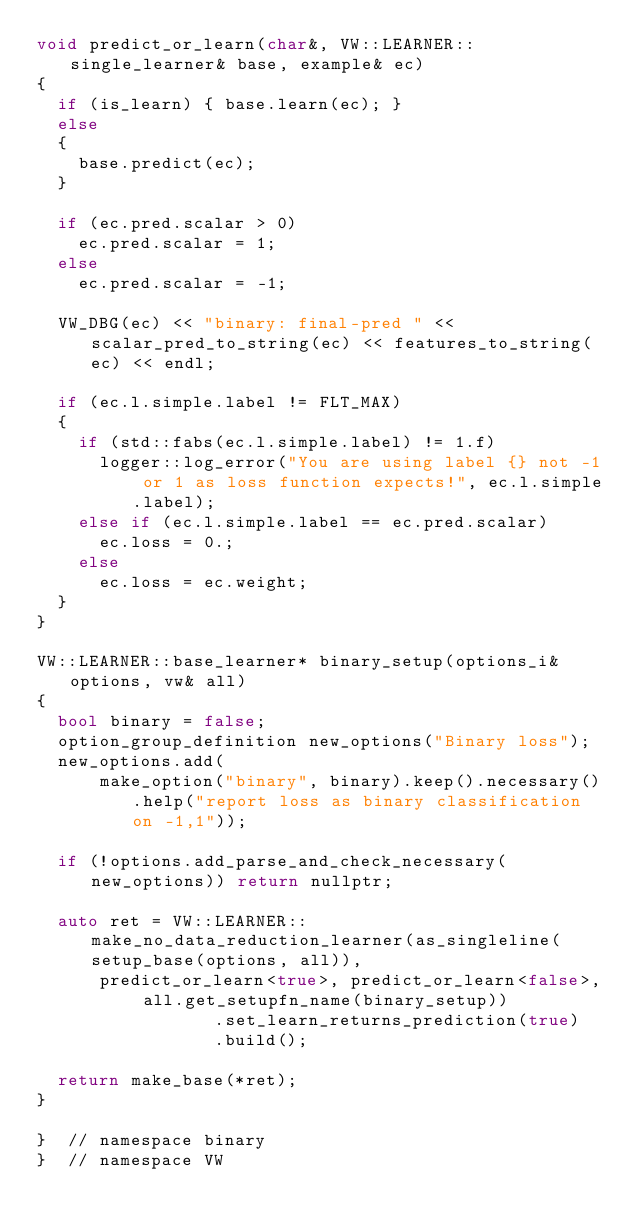Convert code to text. <code><loc_0><loc_0><loc_500><loc_500><_C++_>void predict_or_learn(char&, VW::LEARNER::single_learner& base, example& ec)
{
  if (is_learn) { base.learn(ec); }
  else
  {
    base.predict(ec);
  }

  if (ec.pred.scalar > 0)
    ec.pred.scalar = 1;
  else
    ec.pred.scalar = -1;

  VW_DBG(ec) << "binary: final-pred " << scalar_pred_to_string(ec) << features_to_string(ec) << endl;

  if (ec.l.simple.label != FLT_MAX)
  {
    if (std::fabs(ec.l.simple.label) != 1.f)
      logger::log_error("You are using label {} not -1 or 1 as loss function expects!", ec.l.simple.label);
    else if (ec.l.simple.label == ec.pred.scalar)
      ec.loss = 0.;
    else
      ec.loss = ec.weight;
  }
}

VW::LEARNER::base_learner* binary_setup(options_i& options, vw& all)
{
  bool binary = false;
  option_group_definition new_options("Binary loss");
  new_options.add(
      make_option("binary", binary).keep().necessary().help("report loss as binary classification on -1,1"));

  if (!options.add_parse_and_check_necessary(new_options)) return nullptr;

  auto ret = VW::LEARNER::make_no_data_reduction_learner(as_singleline(setup_base(options, all)),
      predict_or_learn<true>, predict_or_learn<false>, all.get_setupfn_name(binary_setup))
                 .set_learn_returns_prediction(true)
                 .build();

  return make_base(*ret);
}

}  // namespace binary
}  // namespace VW
</code> 